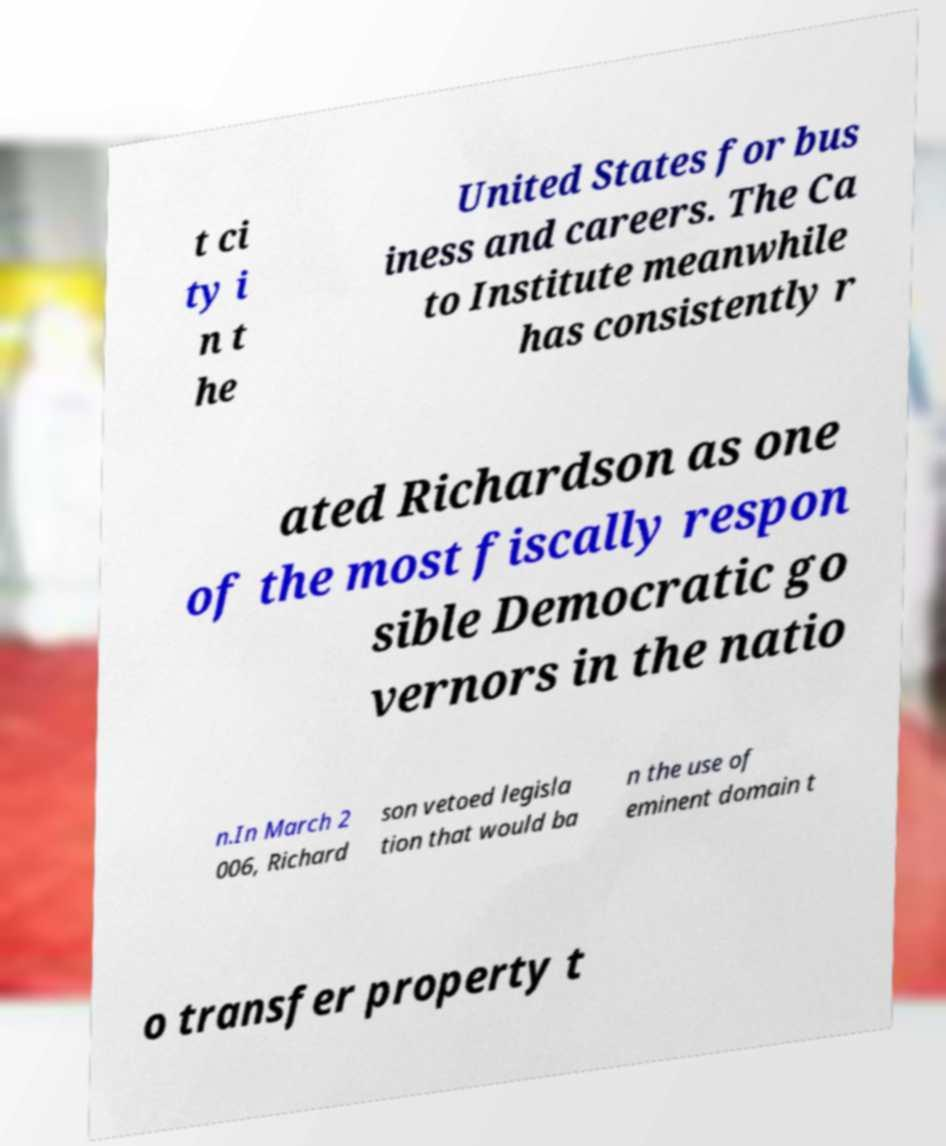What messages or text are displayed in this image? I need them in a readable, typed format. t ci ty i n t he United States for bus iness and careers. The Ca to Institute meanwhile has consistently r ated Richardson as one of the most fiscally respon sible Democratic go vernors in the natio n.In March 2 006, Richard son vetoed legisla tion that would ba n the use of eminent domain t o transfer property t 